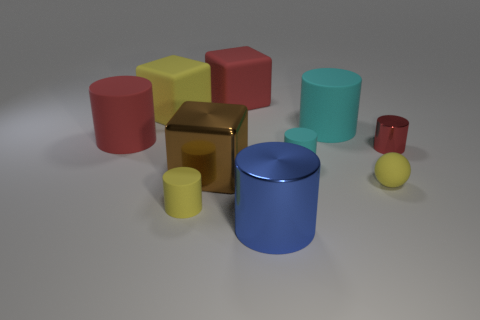Are there any other things that have the same size as the brown object?
Keep it short and to the point. Yes. Is the shape of the large yellow object the same as the cyan object in front of the small metal cylinder?
Make the answer very short. No. There is a big rubber thing on the right side of the small matte cylinder that is behind the tiny thing to the left of the red block; what color is it?
Your answer should be very brief. Cyan. What number of things are yellow matte objects that are behind the large brown cube or large metallic objects behind the tiny rubber sphere?
Your answer should be very brief. 2. How many other things are there of the same color as the small metallic object?
Keep it short and to the point. 2. There is a red rubber thing to the right of the large red matte cylinder; is it the same shape as the tiny shiny thing?
Provide a short and direct response. No. Are there fewer large red objects that are on the left side of the tiny yellow cylinder than tiny green rubber things?
Provide a succinct answer. No. Are there any large gray things made of the same material as the ball?
Your answer should be compact. No. There is a brown object that is the same size as the blue shiny cylinder; what material is it?
Make the answer very short. Metal. Are there fewer yellow spheres that are left of the large yellow thing than small cylinders left of the brown object?
Keep it short and to the point. Yes. 